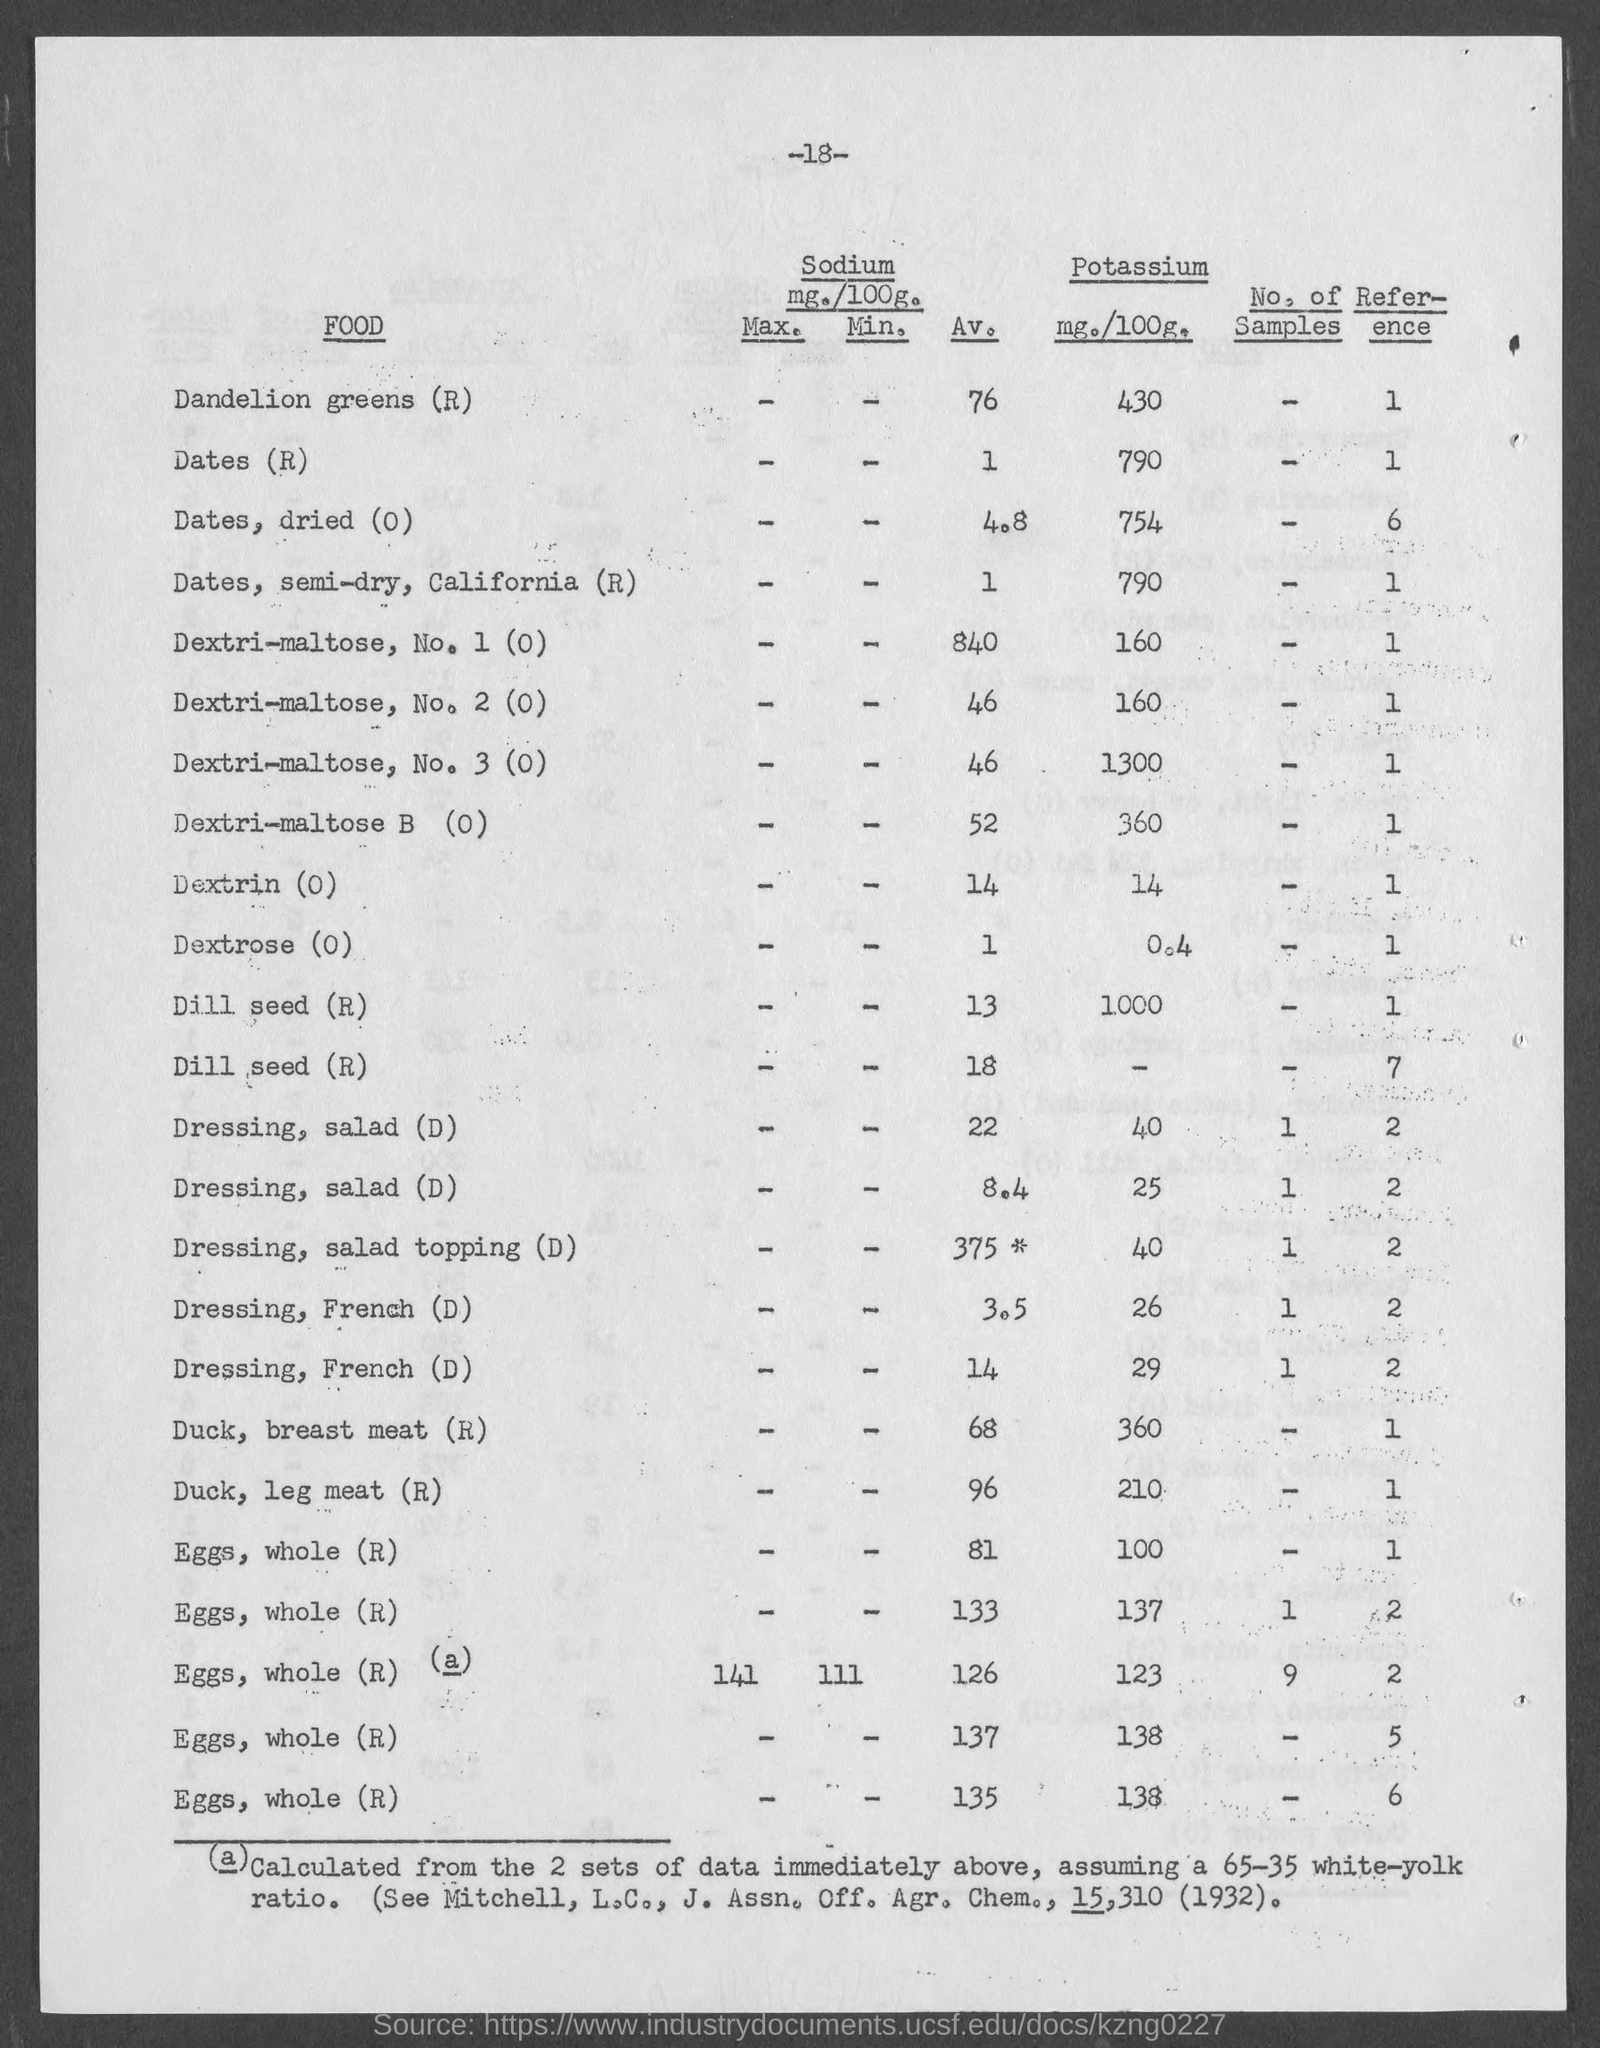What is the max sodium value of eggs,whole?
Give a very brief answer. 141. 